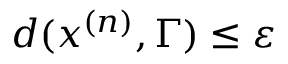Convert formula to latex. <formula><loc_0><loc_0><loc_500><loc_500>d ( x ^ { ( n ) } , \Gamma ) \leq \varepsilon</formula> 